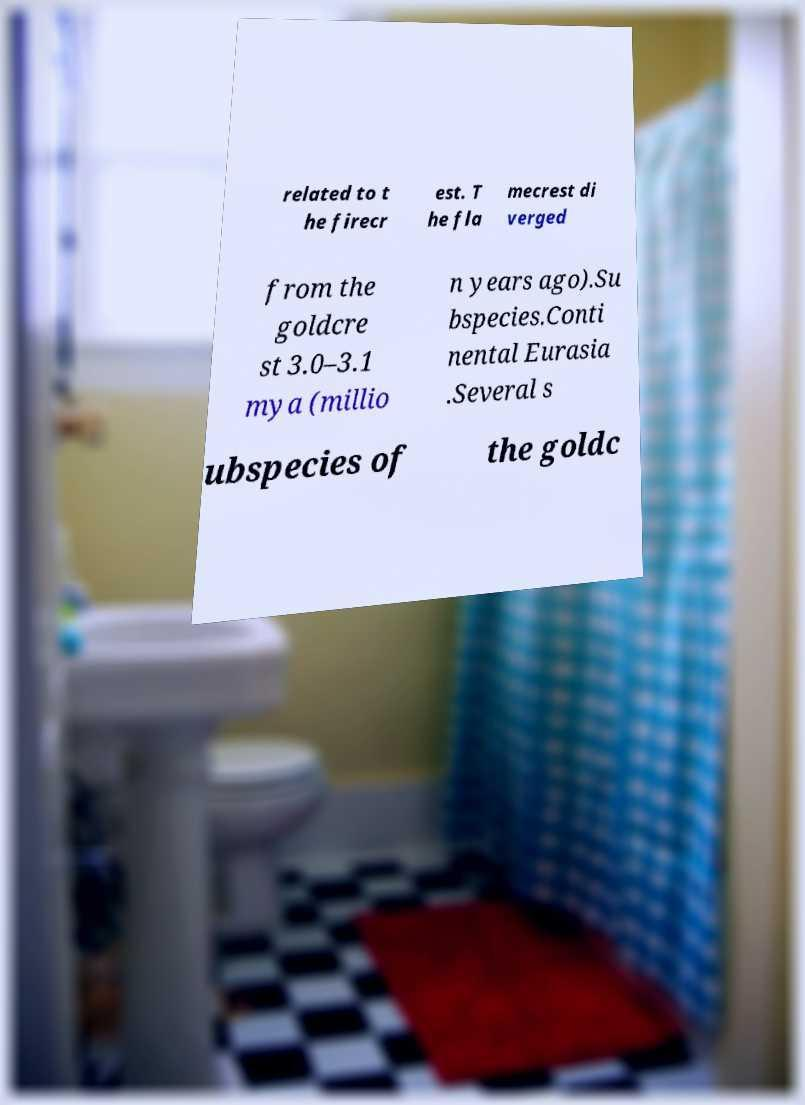Could you extract and type out the text from this image? related to t he firecr est. T he fla mecrest di verged from the goldcre st 3.0–3.1 mya (millio n years ago).Su bspecies.Conti nental Eurasia .Several s ubspecies of the goldc 